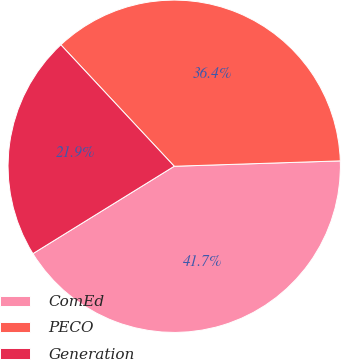<chart> <loc_0><loc_0><loc_500><loc_500><pie_chart><fcel>ComEd<fcel>PECO<fcel>Generation<nl><fcel>41.7%<fcel>36.44%<fcel>21.86%<nl></chart> 